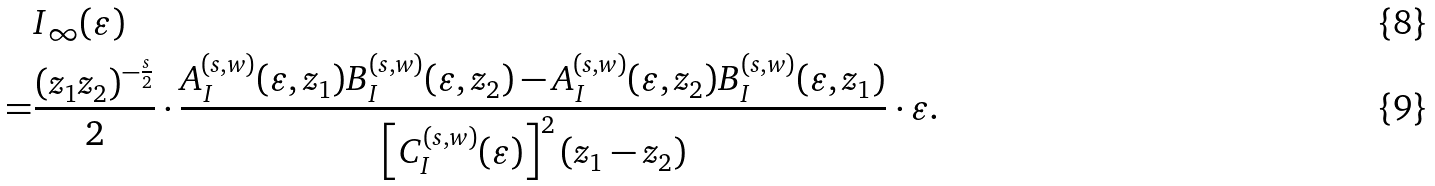<formula> <loc_0><loc_0><loc_500><loc_500>& I _ { \infty } ( \varepsilon ) \\ = & \frac { ( z _ { 1 } z _ { 2 } ) ^ { - \frac { s } { 2 } } } { 2 } \cdot \frac { A _ { I } ^ { ( s , w ) } ( \varepsilon , z _ { 1 } ) B _ { I } ^ { ( s , w ) } ( \varepsilon , z _ { 2 } ) - A _ { I } ^ { ( s , w ) } ( \varepsilon , z _ { 2 } ) B _ { I } ^ { ( s , w ) } ( \varepsilon , z _ { 1 } ) } { \left [ C _ { I } ^ { ( s , w ) } ( \varepsilon ) \right ] ^ { 2 } ( z _ { 1 } - z _ { 2 } ) } \cdot \varepsilon .</formula> 